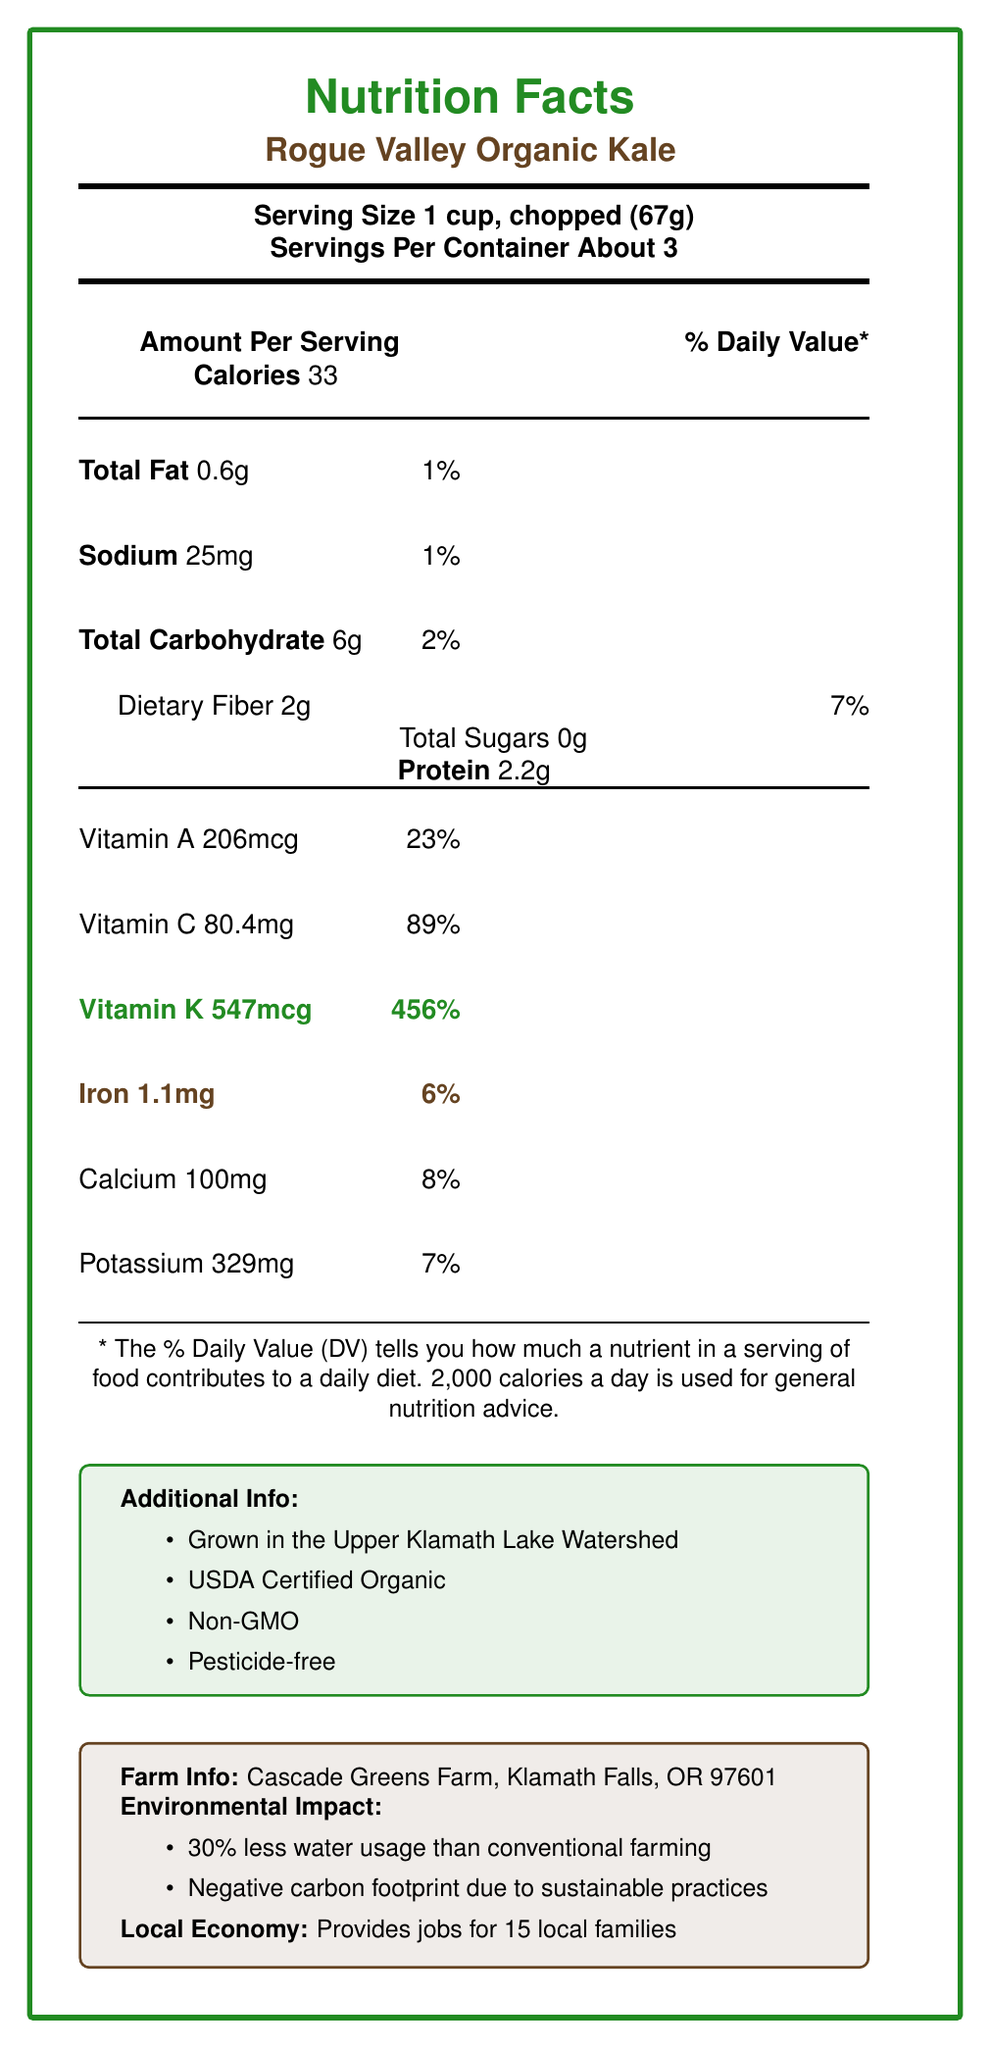what is the serving size? The serving size is mentioned at the top of the document under the product name and basic nutrition facts.
Answer: 1 cup, chopped (67g) how many calories are in one serving of Rogue Valley Organic Kale? The calorie content for one serving is listed clearly under the "Amount Per Serving" section.
Answer: 33 how much vitamin K is in one serving, and what percentage of the daily value does it represent? The amount of vitamin K is prominently highlighted in green text, which states 547mcg, and the daily value percentage is listed as 456%.
Answer: 547mcg, 456% how much iron is in a serving of the kale? The iron content is stated under the vitamin and mineral information section and is highlighted in brown text as 1.1mg.
Answer: 1.1mg how much dietary fiber does a serving of Rogue Valley Organic Kale contain? The dietary fiber content of 2g is located under the total carbohydrate section.
Answer: 2g which organization certifies the kale as organic? A. USDA B. FDA C. EPA The document lists "USDA Certified Organic" under the additional information section.
Answer: A where is Cascade Greens Farm located? A. Portland, OR B. Eugene, OR C. Klamath Falls, OR The farm's location is specified in the farm info section as Klamath Falls, OR.
Answer: C does Rogue Valley Organic Kale contain any added sugars? The document states that the total sugars amount is 0g under the carbohydrate section.
Answer: No is the Rogue Valley Organic Kale pesticide-free? The document mentions "Pesticide-free" in the additional information section.
Answer: Yes summarize the main nutritional benefits and environmental impacts of Rogue Valley Organic Kale. The summary captures key nutritional benefits such as high Vitamin K and Vitamin C content. It also highlights the kale's support for local jobs, sustainable farming practices, and lower environmental impact.
Answer: Rogue Valley Organic Kale provides substantial amounts of Vitamin K (456% DV) and Vitamin C (89% DV). It also supports local economy and sustainable farming practices, using 30% less water, and has a negative carbon footprint. how many types of kale are grown by Cascade Greens Farm? The document lists three varieties: Lacinato (Dinosaur) Kale, Red Russian Kale, and Curly Kale.
Answer: Three is the kale's farming method contributing positively to soil health? The document mentions that the kale is grown using regenerative agriculture techniques, which help to maintain soil fertility.
Answer: Yes how long can the kale be stored in the refrigerator? The storage tips section advises storing the kale in a plastic bag in the refrigerator for up to 5 days.
Answer: Up to 5 days how much protein is in a single serving of Rogue Valley Organic Kale? The protein content is listed under the main nutritional information section.
Answer: 2.2g what is the specific carbon footprint status of Rogue Valley Organic Kale? The environmental impact section states that the farming practices lead to a negative carbon footprint.
Answer: Negative carbon footprint what are some ways to prepare Rogue Valley Organic Kale? The preparation suggestions section provides these methods for using the kale.
Answer: Raw in salads, sautéed with garlic and olive oil, added to soups and stews, baked into crispy kale chips is there any information on the vitamin D content of Rogue Valley Organic Kale? The document does not provide any information regarding the vitamin D content.
Answer: Not enough information what is the main document's theme and key information provided? The main theme revolves around the nutritional benefits, organic farming practices, environmental impact, and local economic support for Rogue Valley Organic Kale.
Answer: The document provides nutritional information for Rogue Valley Organic Kale, highlights its organic and local farming origins, and presents its environmental benefits and local economic contributions. 